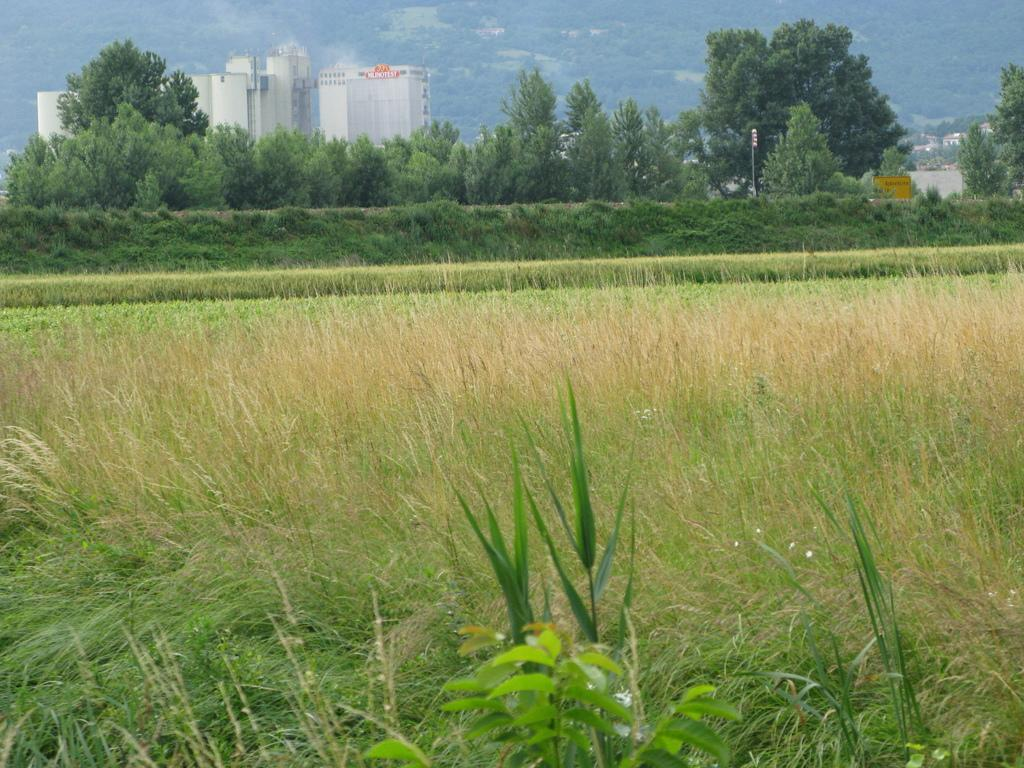What type of structures can be seen in the image? There are buildings in the image. What other natural elements are present in the image? There are trees and poles in the image. What can be seen in the background of the image? There are trees on a mountain in the background of the image. What is visible in the foreground of the image? There is grass and plants in the foreground of the image. Can you tell me how many gloves are being used to play with the match in the image? There is no glove or match present in the image. 